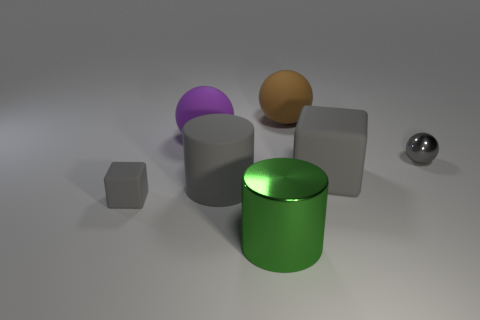Does the small sphere have the same color as the big block?
Provide a succinct answer. Yes. The tiny shiny object that is the same color as the big rubber cylinder is what shape?
Offer a terse response. Sphere. What size is the ball that is the same material as the large green object?
Your response must be concise. Small. The large gray object that is on the left side of the gray rubber block that is to the right of the rubber cube in front of the rubber cylinder is what shape?
Your response must be concise. Cylinder. Is the number of tiny rubber blocks that are right of the green thing the same as the number of big shiny cylinders?
Ensure brevity in your answer.  No. There is another cube that is the same color as the small block; what size is it?
Your answer should be very brief. Large. Do the brown rubber object and the large purple matte object have the same shape?
Offer a terse response. Yes. What number of things are matte things that are right of the large purple matte sphere or shiny spheres?
Your answer should be compact. 4. Is the number of gray matte things to the left of the tiny gray rubber cube the same as the number of matte cubes in front of the gray rubber cylinder?
Ensure brevity in your answer.  No. What number of other things are the same shape as the small gray rubber object?
Offer a very short reply. 1. 